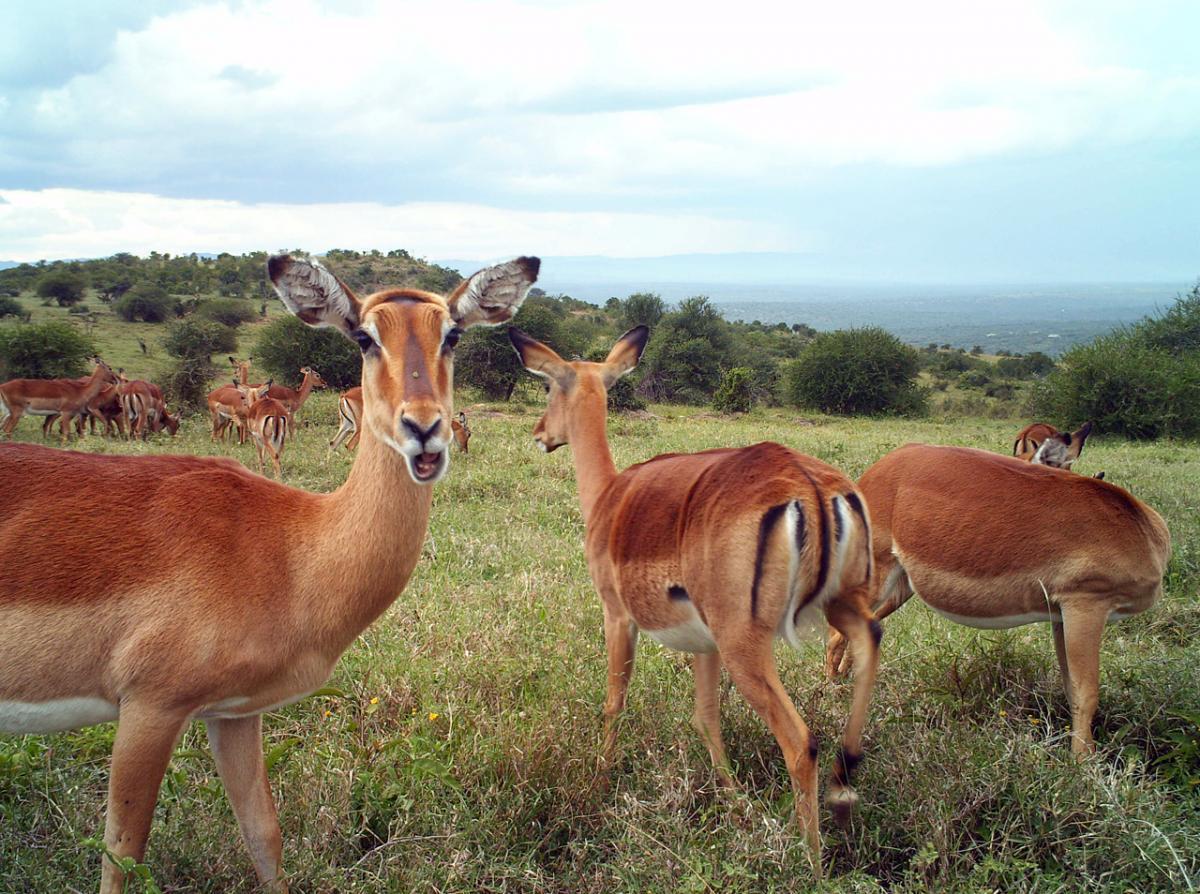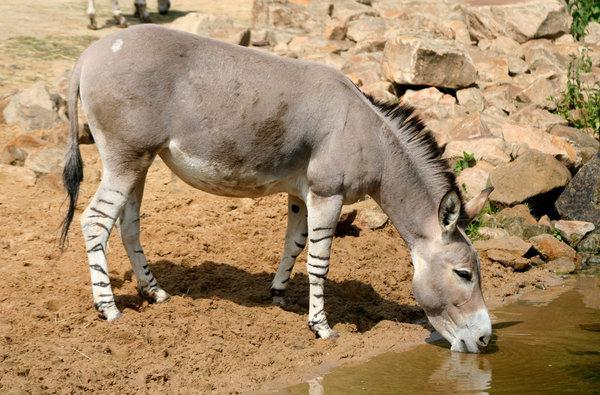The first image is the image on the left, the second image is the image on the right. Evaluate the accuracy of this statement regarding the images: "A herd of elephants mills about behind another type of animal.". Is it true? Answer yes or no. No. 